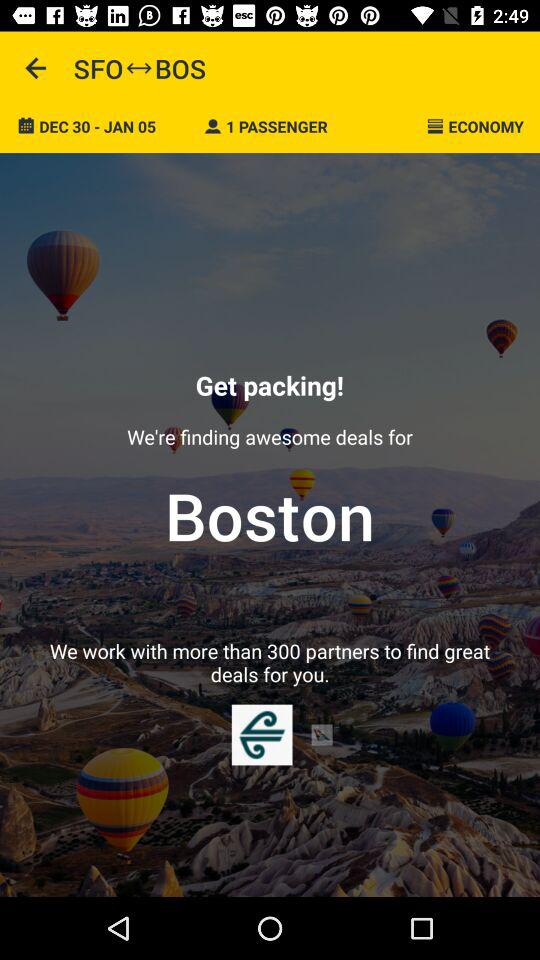What is the application name? The application name is "Air NZ". 